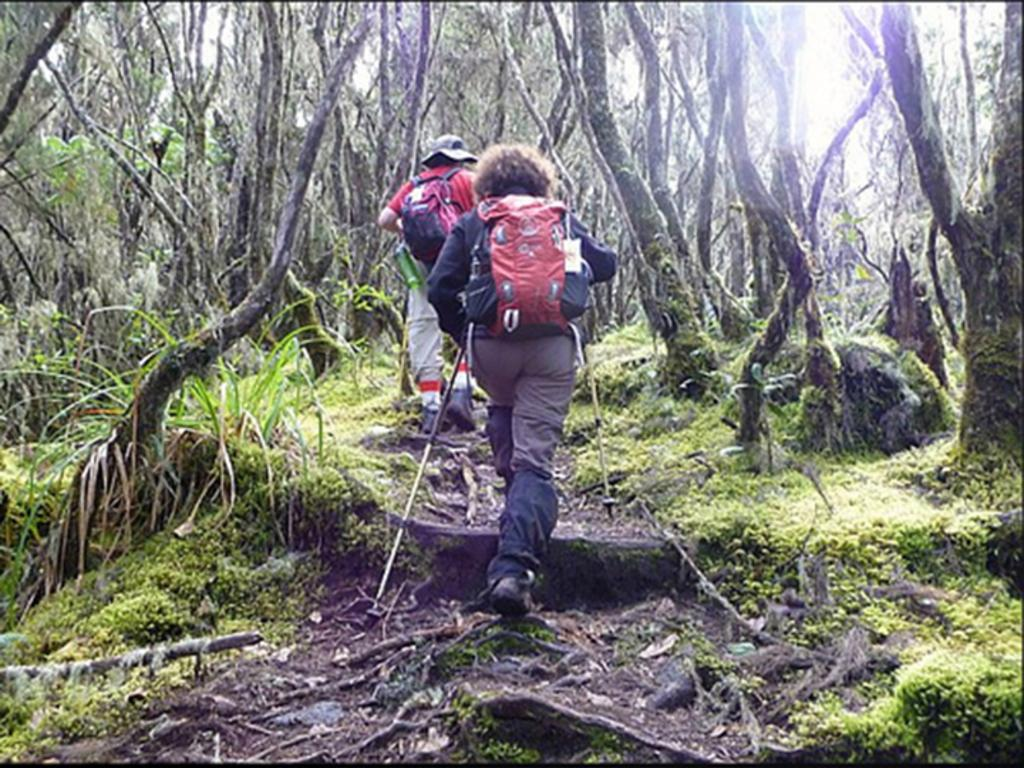How many people are in the image? There are two persons in the image. What are the two persons wearing on their backs? The two persons are wearing backpacks. What are the two persons doing in the image? The two persons are walking on the ground. Can you describe the person holding a stick in the image? There is a person holding a stick in the image. What type of vegetation can be seen in the image? There are trees in the image. What type of machine can be seen working on the ground in the image? There is no machine working on the ground in the image; it features two persons walking on the ground. Can you tell me how many potatoes are visible in the image? There are no potatoes present in the image. 